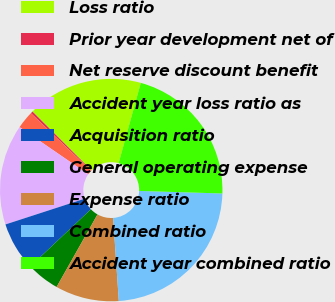<chart> <loc_0><loc_0><loc_500><loc_500><pie_chart><fcel>Loss ratio<fcel>Prior year development net of<fcel>Net reserve discount benefit<fcel>Accident year loss ratio as<fcel>Acquisition ratio<fcel>General operating expense<fcel>Expense ratio<fcel>Combined ratio<fcel>Accident year combined ratio<nl><fcel>16.81%<fcel>0.33%<fcel>2.57%<fcel>14.58%<fcel>7.03%<fcel>4.8%<fcel>9.26%<fcel>23.43%<fcel>21.2%<nl></chart> 